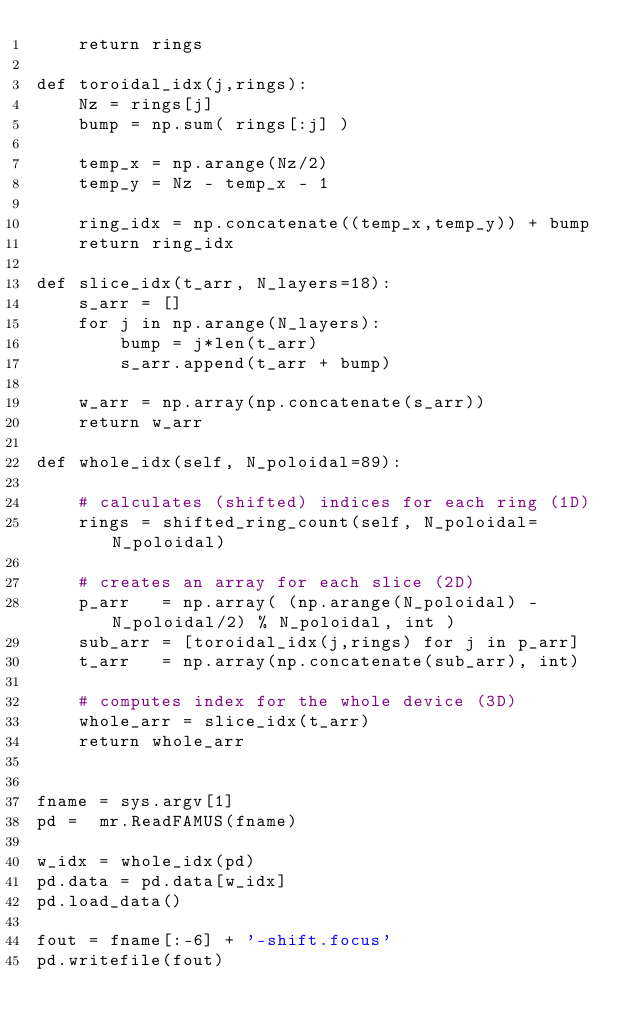Convert code to text. <code><loc_0><loc_0><loc_500><loc_500><_Python_>    return rings

def toroidal_idx(j,rings):
    Nz = rings[j]
    bump = np.sum( rings[:j] )

    temp_x = np.arange(Nz/2)
    temp_y = Nz - temp_x - 1

    ring_idx = np.concatenate((temp_x,temp_y)) + bump
    return ring_idx

def slice_idx(t_arr, N_layers=18):
    s_arr = []
    for j in np.arange(N_layers):
        bump = j*len(t_arr)
        s_arr.append(t_arr + bump)

    w_arr = np.array(np.concatenate(s_arr))
    return w_arr

def whole_idx(self, N_poloidal=89):
    
    # calculates (shifted) indices for each ring (1D)
    rings = shifted_ring_count(self, N_poloidal=N_poloidal)
    
    # creates an array for each slice (2D)
    p_arr   = np.array( (np.arange(N_poloidal) - N_poloidal/2) % N_poloidal, int )
    sub_arr = [toroidal_idx(j,rings) for j in p_arr]
    t_arr   = np.array(np.concatenate(sub_arr), int)
    
    # computes index for the whole device (3D)
    whole_arr = slice_idx(t_arr)
    return whole_arr


fname = sys.argv[1]
pd =  mr.ReadFAMUS(fname)

w_idx = whole_idx(pd)
pd.data = pd.data[w_idx]
pd.load_data()

fout = fname[:-6] + '-shift.focus'
pd.writefile(fout)
</code> 